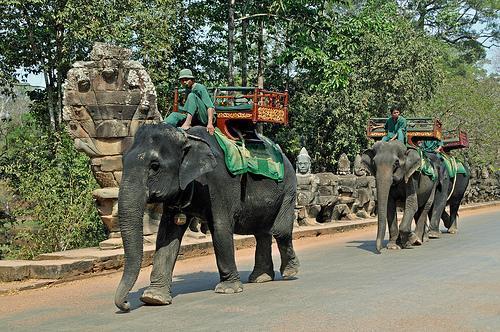How many elephants are in the picture?
Give a very brief answer. 3. 